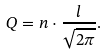Convert formula to latex. <formula><loc_0><loc_0><loc_500><loc_500>Q & = n \cdot \frac { l } { \sqrt { 2 \pi } } .</formula> 